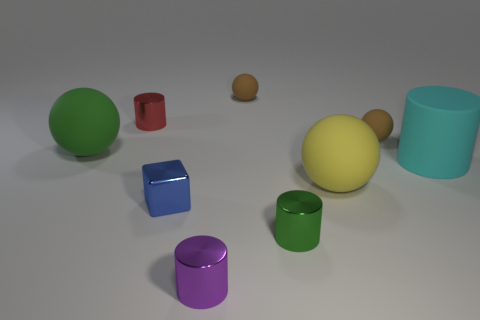Subtract 1 balls. How many balls are left? 3 Subtract all cyan cylinders. How many cylinders are left? 3 Subtract all blue balls. Subtract all cyan blocks. How many balls are left? 4 Add 1 metallic cylinders. How many objects exist? 10 Subtract all spheres. How many objects are left? 5 Subtract all large green rubber objects. Subtract all big green spheres. How many objects are left? 7 Add 4 green metallic things. How many green metallic things are left? 5 Add 5 large rubber balls. How many large rubber balls exist? 7 Subtract 0 red blocks. How many objects are left? 9 